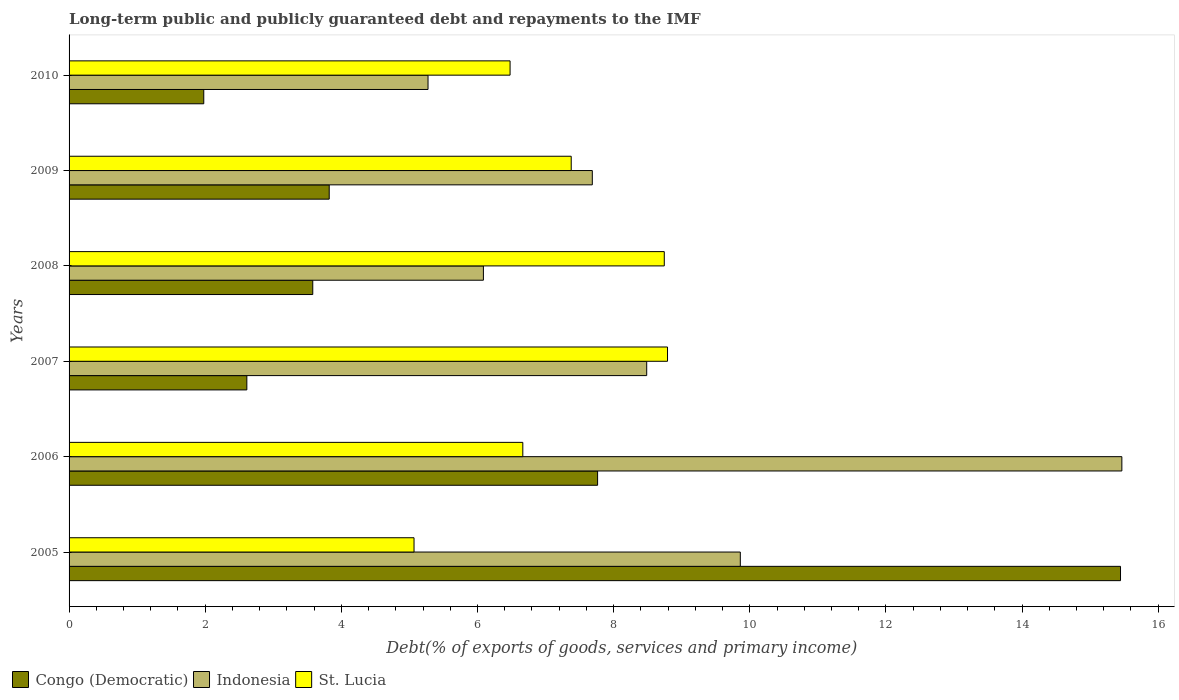Are the number of bars on each tick of the Y-axis equal?
Offer a very short reply. Yes. How many bars are there on the 3rd tick from the top?
Ensure brevity in your answer.  3. How many bars are there on the 3rd tick from the bottom?
Make the answer very short. 3. In how many cases, is the number of bars for a given year not equal to the number of legend labels?
Offer a terse response. 0. What is the debt and repayments in St. Lucia in 2007?
Give a very brief answer. 8.79. Across all years, what is the maximum debt and repayments in Congo (Democratic)?
Your answer should be very brief. 15.45. Across all years, what is the minimum debt and repayments in Congo (Democratic)?
Your answer should be compact. 1.98. In which year was the debt and repayments in Congo (Democratic) maximum?
Make the answer very short. 2005. In which year was the debt and repayments in Congo (Democratic) minimum?
Your response must be concise. 2010. What is the total debt and repayments in Congo (Democratic) in the graph?
Your answer should be compact. 35.2. What is the difference between the debt and repayments in Congo (Democratic) in 2009 and that in 2010?
Offer a very short reply. 1.84. What is the difference between the debt and repayments in Indonesia in 2010 and the debt and repayments in Congo (Democratic) in 2006?
Make the answer very short. -2.49. What is the average debt and repayments in St. Lucia per year?
Provide a succinct answer. 7.19. In the year 2006, what is the difference between the debt and repayments in Congo (Democratic) and debt and repayments in St. Lucia?
Give a very brief answer. 1.1. In how many years, is the debt and repayments in Congo (Democratic) greater than 4 %?
Offer a very short reply. 2. What is the ratio of the debt and repayments in Indonesia in 2008 to that in 2010?
Make the answer very short. 1.15. Is the difference between the debt and repayments in Congo (Democratic) in 2005 and 2009 greater than the difference between the debt and repayments in St. Lucia in 2005 and 2009?
Provide a short and direct response. Yes. What is the difference between the highest and the second highest debt and repayments in Congo (Democratic)?
Offer a very short reply. 7.68. What is the difference between the highest and the lowest debt and repayments in St. Lucia?
Provide a succinct answer. 3.72. Is the sum of the debt and repayments in Indonesia in 2006 and 2009 greater than the maximum debt and repayments in Congo (Democratic) across all years?
Offer a very short reply. Yes. What does the 3rd bar from the top in 2007 represents?
Provide a succinct answer. Congo (Democratic). What does the 1st bar from the bottom in 2007 represents?
Your answer should be very brief. Congo (Democratic). How many bars are there?
Your response must be concise. 18. How many years are there in the graph?
Give a very brief answer. 6. Does the graph contain any zero values?
Provide a short and direct response. No. Does the graph contain grids?
Make the answer very short. No. Where does the legend appear in the graph?
Give a very brief answer. Bottom left. How many legend labels are there?
Your answer should be compact. 3. How are the legend labels stacked?
Ensure brevity in your answer.  Horizontal. What is the title of the graph?
Offer a terse response. Long-term public and publicly guaranteed debt and repayments to the IMF. What is the label or title of the X-axis?
Offer a terse response. Debt(% of exports of goods, services and primary income). What is the label or title of the Y-axis?
Make the answer very short. Years. What is the Debt(% of exports of goods, services and primary income) in Congo (Democratic) in 2005?
Give a very brief answer. 15.45. What is the Debt(% of exports of goods, services and primary income) in Indonesia in 2005?
Your answer should be compact. 9.86. What is the Debt(% of exports of goods, services and primary income) in St. Lucia in 2005?
Ensure brevity in your answer.  5.07. What is the Debt(% of exports of goods, services and primary income) of Congo (Democratic) in 2006?
Your answer should be compact. 7.76. What is the Debt(% of exports of goods, services and primary income) in Indonesia in 2006?
Your answer should be very brief. 15.47. What is the Debt(% of exports of goods, services and primary income) in St. Lucia in 2006?
Your answer should be very brief. 6.67. What is the Debt(% of exports of goods, services and primary income) of Congo (Democratic) in 2007?
Give a very brief answer. 2.61. What is the Debt(% of exports of goods, services and primary income) of Indonesia in 2007?
Offer a very short reply. 8.49. What is the Debt(% of exports of goods, services and primary income) of St. Lucia in 2007?
Your answer should be compact. 8.79. What is the Debt(% of exports of goods, services and primary income) of Congo (Democratic) in 2008?
Your answer should be compact. 3.58. What is the Debt(% of exports of goods, services and primary income) of Indonesia in 2008?
Make the answer very short. 6.09. What is the Debt(% of exports of goods, services and primary income) of St. Lucia in 2008?
Offer a terse response. 8.74. What is the Debt(% of exports of goods, services and primary income) in Congo (Democratic) in 2009?
Ensure brevity in your answer.  3.82. What is the Debt(% of exports of goods, services and primary income) of Indonesia in 2009?
Offer a terse response. 7.69. What is the Debt(% of exports of goods, services and primary income) of St. Lucia in 2009?
Provide a succinct answer. 7.38. What is the Debt(% of exports of goods, services and primary income) of Congo (Democratic) in 2010?
Your answer should be very brief. 1.98. What is the Debt(% of exports of goods, services and primary income) in Indonesia in 2010?
Give a very brief answer. 5.27. What is the Debt(% of exports of goods, services and primary income) in St. Lucia in 2010?
Your answer should be compact. 6.48. Across all years, what is the maximum Debt(% of exports of goods, services and primary income) in Congo (Democratic)?
Your answer should be compact. 15.45. Across all years, what is the maximum Debt(% of exports of goods, services and primary income) in Indonesia?
Your answer should be compact. 15.47. Across all years, what is the maximum Debt(% of exports of goods, services and primary income) in St. Lucia?
Provide a short and direct response. 8.79. Across all years, what is the minimum Debt(% of exports of goods, services and primary income) of Congo (Democratic)?
Your answer should be very brief. 1.98. Across all years, what is the minimum Debt(% of exports of goods, services and primary income) in Indonesia?
Your answer should be very brief. 5.27. Across all years, what is the minimum Debt(% of exports of goods, services and primary income) of St. Lucia?
Ensure brevity in your answer.  5.07. What is the total Debt(% of exports of goods, services and primary income) in Congo (Democratic) in the graph?
Give a very brief answer. 35.2. What is the total Debt(% of exports of goods, services and primary income) of Indonesia in the graph?
Keep it short and to the point. 52.86. What is the total Debt(% of exports of goods, services and primary income) in St. Lucia in the graph?
Provide a succinct answer. 43.12. What is the difference between the Debt(% of exports of goods, services and primary income) of Congo (Democratic) in 2005 and that in 2006?
Ensure brevity in your answer.  7.68. What is the difference between the Debt(% of exports of goods, services and primary income) in Indonesia in 2005 and that in 2006?
Your response must be concise. -5.61. What is the difference between the Debt(% of exports of goods, services and primary income) in St. Lucia in 2005 and that in 2006?
Make the answer very short. -1.6. What is the difference between the Debt(% of exports of goods, services and primary income) of Congo (Democratic) in 2005 and that in 2007?
Your answer should be compact. 12.84. What is the difference between the Debt(% of exports of goods, services and primary income) in Indonesia in 2005 and that in 2007?
Your answer should be very brief. 1.38. What is the difference between the Debt(% of exports of goods, services and primary income) in St. Lucia in 2005 and that in 2007?
Your answer should be very brief. -3.72. What is the difference between the Debt(% of exports of goods, services and primary income) of Congo (Democratic) in 2005 and that in 2008?
Provide a short and direct response. 11.87. What is the difference between the Debt(% of exports of goods, services and primary income) of Indonesia in 2005 and that in 2008?
Provide a short and direct response. 3.77. What is the difference between the Debt(% of exports of goods, services and primary income) of St. Lucia in 2005 and that in 2008?
Ensure brevity in your answer.  -3.68. What is the difference between the Debt(% of exports of goods, services and primary income) in Congo (Democratic) in 2005 and that in 2009?
Provide a short and direct response. 11.62. What is the difference between the Debt(% of exports of goods, services and primary income) in Indonesia in 2005 and that in 2009?
Your answer should be compact. 2.17. What is the difference between the Debt(% of exports of goods, services and primary income) of St. Lucia in 2005 and that in 2009?
Offer a terse response. -2.31. What is the difference between the Debt(% of exports of goods, services and primary income) of Congo (Democratic) in 2005 and that in 2010?
Keep it short and to the point. 13.47. What is the difference between the Debt(% of exports of goods, services and primary income) of Indonesia in 2005 and that in 2010?
Give a very brief answer. 4.59. What is the difference between the Debt(% of exports of goods, services and primary income) in St. Lucia in 2005 and that in 2010?
Provide a succinct answer. -1.41. What is the difference between the Debt(% of exports of goods, services and primary income) in Congo (Democratic) in 2006 and that in 2007?
Offer a very short reply. 5.15. What is the difference between the Debt(% of exports of goods, services and primary income) of Indonesia in 2006 and that in 2007?
Your response must be concise. 6.98. What is the difference between the Debt(% of exports of goods, services and primary income) of St. Lucia in 2006 and that in 2007?
Make the answer very short. -2.13. What is the difference between the Debt(% of exports of goods, services and primary income) in Congo (Democratic) in 2006 and that in 2008?
Your answer should be compact. 4.18. What is the difference between the Debt(% of exports of goods, services and primary income) in Indonesia in 2006 and that in 2008?
Provide a short and direct response. 9.38. What is the difference between the Debt(% of exports of goods, services and primary income) of St. Lucia in 2006 and that in 2008?
Ensure brevity in your answer.  -2.08. What is the difference between the Debt(% of exports of goods, services and primary income) of Congo (Democratic) in 2006 and that in 2009?
Your response must be concise. 3.94. What is the difference between the Debt(% of exports of goods, services and primary income) in Indonesia in 2006 and that in 2009?
Your answer should be very brief. 7.78. What is the difference between the Debt(% of exports of goods, services and primary income) of St. Lucia in 2006 and that in 2009?
Keep it short and to the point. -0.71. What is the difference between the Debt(% of exports of goods, services and primary income) of Congo (Democratic) in 2006 and that in 2010?
Keep it short and to the point. 5.79. What is the difference between the Debt(% of exports of goods, services and primary income) of Indonesia in 2006 and that in 2010?
Provide a short and direct response. 10.19. What is the difference between the Debt(% of exports of goods, services and primary income) of St. Lucia in 2006 and that in 2010?
Make the answer very short. 0.19. What is the difference between the Debt(% of exports of goods, services and primary income) in Congo (Democratic) in 2007 and that in 2008?
Ensure brevity in your answer.  -0.97. What is the difference between the Debt(% of exports of goods, services and primary income) in Indonesia in 2007 and that in 2008?
Ensure brevity in your answer.  2.4. What is the difference between the Debt(% of exports of goods, services and primary income) of St. Lucia in 2007 and that in 2008?
Make the answer very short. 0.05. What is the difference between the Debt(% of exports of goods, services and primary income) in Congo (Democratic) in 2007 and that in 2009?
Keep it short and to the point. -1.21. What is the difference between the Debt(% of exports of goods, services and primary income) in Indonesia in 2007 and that in 2009?
Provide a succinct answer. 0.8. What is the difference between the Debt(% of exports of goods, services and primary income) in St. Lucia in 2007 and that in 2009?
Keep it short and to the point. 1.41. What is the difference between the Debt(% of exports of goods, services and primary income) in Congo (Democratic) in 2007 and that in 2010?
Make the answer very short. 0.63. What is the difference between the Debt(% of exports of goods, services and primary income) of Indonesia in 2007 and that in 2010?
Keep it short and to the point. 3.21. What is the difference between the Debt(% of exports of goods, services and primary income) of St. Lucia in 2007 and that in 2010?
Your answer should be very brief. 2.31. What is the difference between the Debt(% of exports of goods, services and primary income) of Congo (Democratic) in 2008 and that in 2009?
Ensure brevity in your answer.  -0.24. What is the difference between the Debt(% of exports of goods, services and primary income) in Indonesia in 2008 and that in 2009?
Keep it short and to the point. -1.6. What is the difference between the Debt(% of exports of goods, services and primary income) of St. Lucia in 2008 and that in 2009?
Keep it short and to the point. 1.37. What is the difference between the Debt(% of exports of goods, services and primary income) of Congo (Democratic) in 2008 and that in 2010?
Make the answer very short. 1.6. What is the difference between the Debt(% of exports of goods, services and primary income) of Indonesia in 2008 and that in 2010?
Make the answer very short. 0.81. What is the difference between the Debt(% of exports of goods, services and primary income) of St. Lucia in 2008 and that in 2010?
Your response must be concise. 2.27. What is the difference between the Debt(% of exports of goods, services and primary income) in Congo (Democratic) in 2009 and that in 2010?
Provide a short and direct response. 1.84. What is the difference between the Debt(% of exports of goods, services and primary income) in Indonesia in 2009 and that in 2010?
Keep it short and to the point. 2.41. What is the difference between the Debt(% of exports of goods, services and primary income) of St. Lucia in 2009 and that in 2010?
Offer a very short reply. 0.9. What is the difference between the Debt(% of exports of goods, services and primary income) in Congo (Democratic) in 2005 and the Debt(% of exports of goods, services and primary income) in Indonesia in 2006?
Ensure brevity in your answer.  -0.02. What is the difference between the Debt(% of exports of goods, services and primary income) in Congo (Democratic) in 2005 and the Debt(% of exports of goods, services and primary income) in St. Lucia in 2006?
Provide a succinct answer. 8.78. What is the difference between the Debt(% of exports of goods, services and primary income) of Indonesia in 2005 and the Debt(% of exports of goods, services and primary income) of St. Lucia in 2006?
Keep it short and to the point. 3.2. What is the difference between the Debt(% of exports of goods, services and primary income) of Congo (Democratic) in 2005 and the Debt(% of exports of goods, services and primary income) of Indonesia in 2007?
Your answer should be very brief. 6.96. What is the difference between the Debt(% of exports of goods, services and primary income) in Congo (Democratic) in 2005 and the Debt(% of exports of goods, services and primary income) in St. Lucia in 2007?
Your answer should be very brief. 6.65. What is the difference between the Debt(% of exports of goods, services and primary income) in Indonesia in 2005 and the Debt(% of exports of goods, services and primary income) in St. Lucia in 2007?
Make the answer very short. 1.07. What is the difference between the Debt(% of exports of goods, services and primary income) in Congo (Democratic) in 2005 and the Debt(% of exports of goods, services and primary income) in Indonesia in 2008?
Provide a succinct answer. 9.36. What is the difference between the Debt(% of exports of goods, services and primary income) of Congo (Democratic) in 2005 and the Debt(% of exports of goods, services and primary income) of St. Lucia in 2008?
Ensure brevity in your answer.  6.7. What is the difference between the Debt(% of exports of goods, services and primary income) of Indonesia in 2005 and the Debt(% of exports of goods, services and primary income) of St. Lucia in 2008?
Provide a succinct answer. 1.12. What is the difference between the Debt(% of exports of goods, services and primary income) of Congo (Democratic) in 2005 and the Debt(% of exports of goods, services and primary income) of Indonesia in 2009?
Make the answer very short. 7.76. What is the difference between the Debt(% of exports of goods, services and primary income) in Congo (Democratic) in 2005 and the Debt(% of exports of goods, services and primary income) in St. Lucia in 2009?
Offer a terse response. 8.07. What is the difference between the Debt(% of exports of goods, services and primary income) of Indonesia in 2005 and the Debt(% of exports of goods, services and primary income) of St. Lucia in 2009?
Your answer should be very brief. 2.48. What is the difference between the Debt(% of exports of goods, services and primary income) of Congo (Democratic) in 2005 and the Debt(% of exports of goods, services and primary income) of Indonesia in 2010?
Your answer should be very brief. 10.17. What is the difference between the Debt(% of exports of goods, services and primary income) of Congo (Democratic) in 2005 and the Debt(% of exports of goods, services and primary income) of St. Lucia in 2010?
Provide a short and direct response. 8.97. What is the difference between the Debt(% of exports of goods, services and primary income) of Indonesia in 2005 and the Debt(% of exports of goods, services and primary income) of St. Lucia in 2010?
Give a very brief answer. 3.38. What is the difference between the Debt(% of exports of goods, services and primary income) in Congo (Democratic) in 2006 and the Debt(% of exports of goods, services and primary income) in Indonesia in 2007?
Provide a succinct answer. -0.72. What is the difference between the Debt(% of exports of goods, services and primary income) of Congo (Democratic) in 2006 and the Debt(% of exports of goods, services and primary income) of St. Lucia in 2007?
Make the answer very short. -1.03. What is the difference between the Debt(% of exports of goods, services and primary income) of Indonesia in 2006 and the Debt(% of exports of goods, services and primary income) of St. Lucia in 2007?
Offer a very short reply. 6.67. What is the difference between the Debt(% of exports of goods, services and primary income) of Congo (Democratic) in 2006 and the Debt(% of exports of goods, services and primary income) of Indonesia in 2008?
Make the answer very short. 1.68. What is the difference between the Debt(% of exports of goods, services and primary income) in Congo (Democratic) in 2006 and the Debt(% of exports of goods, services and primary income) in St. Lucia in 2008?
Your answer should be compact. -0.98. What is the difference between the Debt(% of exports of goods, services and primary income) of Indonesia in 2006 and the Debt(% of exports of goods, services and primary income) of St. Lucia in 2008?
Offer a terse response. 6.72. What is the difference between the Debt(% of exports of goods, services and primary income) of Congo (Democratic) in 2006 and the Debt(% of exports of goods, services and primary income) of Indonesia in 2009?
Keep it short and to the point. 0.08. What is the difference between the Debt(% of exports of goods, services and primary income) of Congo (Democratic) in 2006 and the Debt(% of exports of goods, services and primary income) of St. Lucia in 2009?
Ensure brevity in your answer.  0.39. What is the difference between the Debt(% of exports of goods, services and primary income) in Indonesia in 2006 and the Debt(% of exports of goods, services and primary income) in St. Lucia in 2009?
Offer a terse response. 8.09. What is the difference between the Debt(% of exports of goods, services and primary income) in Congo (Democratic) in 2006 and the Debt(% of exports of goods, services and primary income) in Indonesia in 2010?
Keep it short and to the point. 2.49. What is the difference between the Debt(% of exports of goods, services and primary income) in Congo (Democratic) in 2006 and the Debt(% of exports of goods, services and primary income) in St. Lucia in 2010?
Your answer should be compact. 1.29. What is the difference between the Debt(% of exports of goods, services and primary income) in Indonesia in 2006 and the Debt(% of exports of goods, services and primary income) in St. Lucia in 2010?
Offer a terse response. 8.99. What is the difference between the Debt(% of exports of goods, services and primary income) in Congo (Democratic) in 2007 and the Debt(% of exports of goods, services and primary income) in Indonesia in 2008?
Make the answer very short. -3.48. What is the difference between the Debt(% of exports of goods, services and primary income) of Congo (Democratic) in 2007 and the Debt(% of exports of goods, services and primary income) of St. Lucia in 2008?
Offer a very short reply. -6.13. What is the difference between the Debt(% of exports of goods, services and primary income) in Indonesia in 2007 and the Debt(% of exports of goods, services and primary income) in St. Lucia in 2008?
Offer a terse response. -0.26. What is the difference between the Debt(% of exports of goods, services and primary income) in Congo (Democratic) in 2007 and the Debt(% of exports of goods, services and primary income) in Indonesia in 2009?
Your response must be concise. -5.08. What is the difference between the Debt(% of exports of goods, services and primary income) of Congo (Democratic) in 2007 and the Debt(% of exports of goods, services and primary income) of St. Lucia in 2009?
Make the answer very short. -4.77. What is the difference between the Debt(% of exports of goods, services and primary income) of Indonesia in 2007 and the Debt(% of exports of goods, services and primary income) of St. Lucia in 2009?
Give a very brief answer. 1.11. What is the difference between the Debt(% of exports of goods, services and primary income) in Congo (Democratic) in 2007 and the Debt(% of exports of goods, services and primary income) in Indonesia in 2010?
Make the answer very short. -2.66. What is the difference between the Debt(% of exports of goods, services and primary income) in Congo (Democratic) in 2007 and the Debt(% of exports of goods, services and primary income) in St. Lucia in 2010?
Keep it short and to the point. -3.87. What is the difference between the Debt(% of exports of goods, services and primary income) of Indonesia in 2007 and the Debt(% of exports of goods, services and primary income) of St. Lucia in 2010?
Keep it short and to the point. 2.01. What is the difference between the Debt(% of exports of goods, services and primary income) in Congo (Democratic) in 2008 and the Debt(% of exports of goods, services and primary income) in Indonesia in 2009?
Ensure brevity in your answer.  -4.11. What is the difference between the Debt(% of exports of goods, services and primary income) of Congo (Democratic) in 2008 and the Debt(% of exports of goods, services and primary income) of St. Lucia in 2009?
Ensure brevity in your answer.  -3.8. What is the difference between the Debt(% of exports of goods, services and primary income) in Indonesia in 2008 and the Debt(% of exports of goods, services and primary income) in St. Lucia in 2009?
Keep it short and to the point. -1.29. What is the difference between the Debt(% of exports of goods, services and primary income) in Congo (Democratic) in 2008 and the Debt(% of exports of goods, services and primary income) in Indonesia in 2010?
Keep it short and to the point. -1.69. What is the difference between the Debt(% of exports of goods, services and primary income) in Congo (Democratic) in 2008 and the Debt(% of exports of goods, services and primary income) in St. Lucia in 2010?
Keep it short and to the point. -2.9. What is the difference between the Debt(% of exports of goods, services and primary income) of Indonesia in 2008 and the Debt(% of exports of goods, services and primary income) of St. Lucia in 2010?
Your response must be concise. -0.39. What is the difference between the Debt(% of exports of goods, services and primary income) of Congo (Democratic) in 2009 and the Debt(% of exports of goods, services and primary income) of Indonesia in 2010?
Your answer should be compact. -1.45. What is the difference between the Debt(% of exports of goods, services and primary income) in Congo (Democratic) in 2009 and the Debt(% of exports of goods, services and primary income) in St. Lucia in 2010?
Your response must be concise. -2.66. What is the difference between the Debt(% of exports of goods, services and primary income) of Indonesia in 2009 and the Debt(% of exports of goods, services and primary income) of St. Lucia in 2010?
Provide a succinct answer. 1.21. What is the average Debt(% of exports of goods, services and primary income) in Congo (Democratic) per year?
Give a very brief answer. 5.87. What is the average Debt(% of exports of goods, services and primary income) in Indonesia per year?
Ensure brevity in your answer.  8.81. What is the average Debt(% of exports of goods, services and primary income) in St. Lucia per year?
Your answer should be compact. 7.19. In the year 2005, what is the difference between the Debt(% of exports of goods, services and primary income) of Congo (Democratic) and Debt(% of exports of goods, services and primary income) of Indonesia?
Offer a very short reply. 5.59. In the year 2005, what is the difference between the Debt(% of exports of goods, services and primary income) in Congo (Democratic) and Debt(% of exports of goods, services and primary income) in St. Lucia?
Provide a short and direct response. 10.38. In the year 2005, what is the difference between the Debt(% of exports of goods, services and primary income) in Indonesia and Debt(% of exports of goods, services and primary income) in St. Lucia?
Ensure brevity in your answer.  4.79. In the year 2006, what is the difference between the Debt(% of exports of goods, services and primary income) of Congo (Democratic) and Debt(% of exports of goods, services and primary income) of Indonesia?
Make the answer very short. -7.7. In the year 2006, what is the difference between the Debt(% of exports of goods, services and primary income) in Congo (Democratic) and Debt(% of exports of goods, services and primary income) in St. Lucia?
Offer a very short reply. 1.1. In the year 2006, what is the difference between the Debt(% of exports of goods, services and primary income) of Indonesia and Debt(% of exports of goods, services and primary income) of St. Lucia?
Offer a very short reply. 8.8. In the year 2007, what is the difference between the Debt(% of exports of goods, services and primary income) of Congo (Democratic) and Debt(% of exports of goods, services and primary income) of Indonesia?
Provide a succinct answer. -5.87. In the year 2007, what is the difference between the Debt(% of exports of goods, services and primary income) in Congo (Democratic) and Debt(% of exports of goods, services and primary income) in St. Lucia?
Your answer should be very brief. -6.18. In the year 2007, what is the difference between the Debt(% of exports of goods, services and primary income) of Indonesia and Debt(% of exports of goods, services and primary income) of St. Lucia?
Your response must be concise. -0.31. In the year 2008, what is the difference between the Debt(% of exports of goods, services and primary income) of Congo (Democratic) and Debt(% of exports of goods, services and primary income) of Indonesia?
Ensure brevity in your answer.  -2.51. In the year 2008, what is the difference between the Debt(% of exports of goods, services and primary income) of Congo (Democratic) and Debt(% of exports of goods, services and primary income) of St. Lucia?
Keep it short and to the point. -5.16. In the year 2008, what is the difference between the Debt(% of exports of goods, services and primary income) of Indonesia and Debt(% of exports of goods, services and primary income) of St. Lucia?
Offer a very short reply. -2.66. In the year 2009, what is the difference between the Debt(% of exports of goods, services and primary income) of Congo (Democratic) and Debt(% of exports of goods, services and primary income) of Indonesia?
Keep it short and to the point. -3.87. In the year 2009, what is the difference between the Debt(% of exports of goods, services and primary income) of Congo (Democratic) and Debt(% of exports of goods, services and primary income) of St. Lucia?
Offer a very short reply. -3.56. In the year 2009, what is the difference between the Debt(% of exports of goods, services and primary income) of Indonesia and Debt(% of exports of goods, services and primary income) of St. Lucia?
Your answer should be very brief. 0.31. In the year 2010, what is the difference between the Debt(% of exports of goods, services and primary income) in Congo (Democratic) and Debt(% of exports of goods, services and primary income) in Indonesia?
Your response must be concise. -3.29. In the year 2010, what is the difference between the Debt(% of exports of goods, services and primary income) in Indonesia and Debt(% of exports of goods, services and primary income) in St. Lucia?
Your answer should be compact. -1.21. What is the ratio of the Debt(% of exports of goods, services and primary income) of Congo (Democratic) in 2005 to that in 2006?
Ensure brevity in your answer.  1.99. What is the ratio of the Debt(% of exports of goods, services and primary income) of Indonesia in 2005 to that in 2006?
Make the answer very short. 0.64. What is the ratio of the Debt(% of exports of goods, services and primary income) in St. Lucia in 2005 to that in 2006?
Your response must be concise. 0.76. What is the ratio of the Debt(% of exports of goods, services and primary income) of Congo (Democratic) in 2005 to that in 2007?
Give a very brief answer. 5.91. What is the ratio of the Debt(% of exports of goods, services and primary income) in Indonesia in 2005 to that in 2007?
Offer a very short reply. 1.16. What is the ratio of the Debt(% of exports of goods, services and primary income) of St. Lucia in 2005 to that in 2007?
Offer a very short reply. 0.58. What is the ratio of the Debt(% of exports of goods, services and primary income) of Congo (Democratic) in 2005 to that in 2008?
Offer a terse response. 4.31. What is the ratio of the Debt(% of exports of goods, services and primary income) in Indonesia in 2005 to that in 2008?
Make the answer very short. 1.62. What is the ratio of the Debt(% of exports of goods, services and primary income) of St. Lucia in 2005 to that in 2008?
Offer a very short reply. 0.58. What is the ratio of the Debt(% of exports of goods, services and primary income) of Congo (Democratic) in 2005 to that in 2009?
Your answer should be very brief. 4.04. What is the ratio of the Debt(% of exports of goods, services and primary income) in Indonesia in 2005 to that in 2009?
Offer a terse response. 1.28. What is the ratio of the Debt(% of exports of goods, services and primary income) of St. Lucia in 2005 to that in 2009?
Offer a very short reply. 0.69. What is the ratio of the Debt(% of exports of goods, services and primary income) of Congo (Democratic) in 2005 to that in 2010?
Make the answer very short. 7.81. What is the ratio of the Debt(% of exports of goods, services and primary income) of Indonesia in 2005 to that in 2010?
Offer a terse response. 1.87. What is the ratio of the Debt(% of exports of goods, services and primary income) in St. Lucia in 2005 to that in 2010?
Your answer should be very brief. 0.78. What is the ratio of the Debt(% of exports of goods, services and primary income) of Congo (Democratic) in 2006 to that in 2007?
Ensure brevity in your answer.  2.97. What is the ratio of the Debt(% of exports of goods, services and primary income) of Indonesia in 2006 to that in 2007?
Make the answer very short. 1.82. What is the ratio of the Debt(% of exports of goods, services and primary income) of St. Lucia in 2006 to that in 2007?
Your answer should be very brief. 0.76. What is the ratio of the Debt(% of exports of goods, services and primary income) in Congo (Democratic) in 2006 to that in 2008?
Ensure brevity in your answer.  2.17. What is the ratio of the Debt(% of exports of goods, services and primary income) in Indonesia in 2006 to that in 2008?
Provide a succinct answer. 2.54. What is the ratio of the Debt(% of exports of goods, services and primary income) of St. Lucia in 2006 to that in 2008?
Your answer should be compact. 0.76. What is the ratio of the Debt(% of exports of goods, services and primary income) of Congo (Democratic) in 2006 to that in 2009?
Your response must be concise. 2.03. What is the ratio of the Debt(% of exports of goods, services and primary income) in Indonesia in 2006 to that in 2009?
Ensure brevity in your answer.  2.01. What is the ratio of the Debt(% of exports of goods, services and primary income) of St. Lucia in 2006 to that in 2009?
Ensure brevity in your answer.  0.9. What is the ratio of the Debt(% of exports of goods, services and primary income) in Congo (Democratic) in 2006 to that in 2010?
Offer a very short reply. 3.92. What is the ratio of the Debt(% of exports of goods, services and primary income) of Indonesia in 2006 to that in 2010?
Your answer should be compact. 2.93. What is the ratio of the Debt(% of exports of goods, services and primary income) of St. Lucia in 2006 to that in 2010?
Your response must be concise. 1.03. What is the ratio of the Debt(% of exports of goods, services and primary income) in Congo (Democratic) in 2007 to that in 2008?
Provide a succinct answer. 0.73. What is the ratio of the Debt(% of exports of goods, services and primary income) in Indonesia in 2007 to that in 2008?
Your answer should be compact. 1.39. What is the ratio of the Debt(% of exports of goods, services and primary income) of St. Lucia in 2007 to that in 2008?
Provide a succinct answer. 1.01. What is the ratio of the Debt(% of exports of goods, services and primary income) of Congo (Democratic) in 2007 to that in 2009?
Your answer should be very brief. 0.68. What is the ratio of the Debt(% of exports of goods, services and primary income) of Indonesia in 2007 to that in 2009?
Make the answer very short. 1.1. What is the ratio of the Debt(% of exports of goods, services and primary income) in St. Lucia in 2007 to that in 2009?
Give a very brief answer. 1.19. What is the ratio of the Debt(% of exports of goods, services and primary income) in Congo (Democratic) in 2007 to that in 2010?
Your answer should be very brief. 1.32. What is the ratio of the Debt(% of exports of goods, services and primary income) of Indonesia in 2007 to that in 2010?
Offer a very short reply. 1.61. What is the ratio of the Debt(% of exports of goods, services and primary income) of St. Lucia in 2007 to that in 2010?
Make the answer very short. 1.36. What is the ratio of the Debt(% of exports of goods, services and primary income) of Congo (Democratic) in 2008 to that in 2009?
Ensure brevity in your answer.  0.94. What is the ratio of the Debt(% of exports of goods, services and primary income) of Indonesia in 2008 to that in 2009?
Ensure brevity in your answer.  0.79. What is the ratio of the Debt(% of exports of goods, services and primary income) in St. Lucia in 2008 to that in 2009?
Offer a terse response. 1.19. What is the ratio of the Debt(% of exports of goods, services and primary income) in Congo (Democratic) in 2008 to that in 2010?
Make the answer very short. 1.81. What is the ratio of the Debt(% of exports of goods, services and primary income) of Indonesia in 2008 to that in 2010?
Keep it short and to the point. 1.15. What is the ratio of the Debt(% of exports of goods, services and primary income) in St. Lucia in 2008 to that in 2010?
Provide a short and direct response. 1.35. What is the ratio of the Debt(% of exports of goods, services and primary income) of Congo (Democratic) in 2009 to that in 2010?
Offer a very short reply. 1.93. What is the ratio of the Debt(% of exports of goods, services and primary income) of Indonesia in 2009 to that in 2010?
Make the answer very short. 1.46. What is the ratio of the Debt(% of exports of goods, services and primary income) of St. Lucia in 2009 to that in 2010?
Your response must be concise. 1.14. What is the difference between the highest and the second highest Debt(% of exports of goods, services and primary income) of Congo (Democratic)?
Give a very brief answer. 7.68. What is the difference between the highest and the second highest Debt(% of exports of goods, services and primary income) of Indonesia?
Provide a succinct answer. 5.61. What is the difference between the highest and the second highest Debt(% of exports of goods, services and primary income) of St. Lucia?
Keep it short and to the point. 0.05. What is the difference between the highest and the lowest Debt(% of exports of goods, services and primary income) in Congo (Democratic)?
Offer a terse response. 13.47. What is the difference between the highest and the lowest Debt(% of exports of goods, services and primary income) of Indonesia?
Your answer should be very brief. 10.19. What is the difference between the highest and the lowest Debt(% of exports of goods, services and primary income) in St. Lucia?
Give a very brief answer. 3.72. 